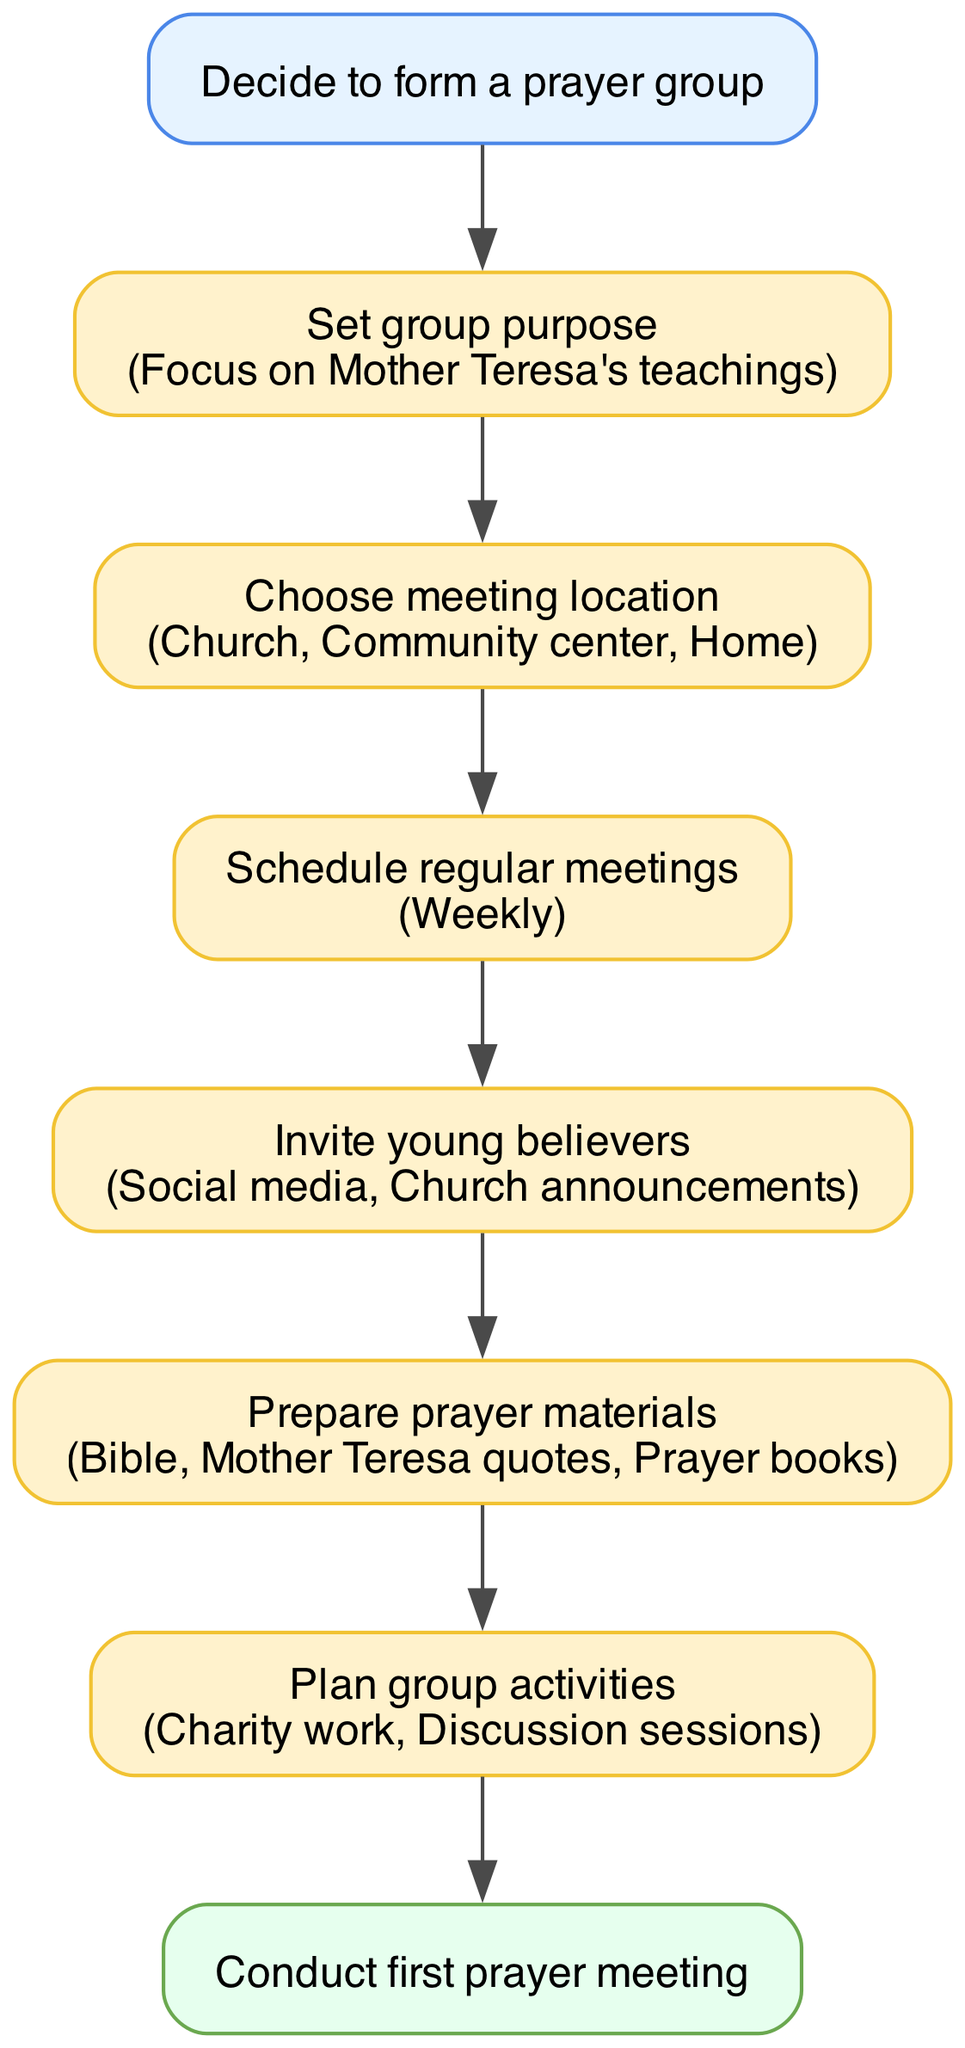What is the first step in establishing a prayer group? The diagram lists "Decide to form a prayer group" as the starting point, indicating that this is the initial action to take.
Answer: Decide to form a prayer group How many steps are there in the process? By counting the steps in the diagram, we see there are six distinct steps before reaching the end.
Answer: Six What options are available for choosing a meeting location? The diagram outlines three options for meeting locations: "Church," "Community center," and "Home."
Answer: Church, Community center, Home What is the scheduled frequency for the meetings? The diagram states that the meetings should be held "Weekly," indicating the regularity expected for the prayer group.
Answer: Weekly What methods can be used to invite young believers? The diagram lists two methods for inviting members: "Social media" and "Church announcements," which are the recommended ways to reach potential attendees.
Answer: Social media, Church announcements Which element is emphasized in setting the group purpose? The diagram highlights a focus on "Mother Teresa's teachings," suggesting that this spiritual guidance is central to the group's mission.
Answer: Mother Teresa's teachings What is the final action to be taken in this flow chart? The diagram indicates that the conclusion of this process is to "Conduct first prayer meeting," which is the ultimate goal of forming the group.
Answer: Conduct first prayer meeting What types of group activities are planned? According to the diagram, examples of activities include "Charity work" and "Discussion sessions," which aim to engage the group beyond just prayer.
Answer: Charity work, Discussion sessions 